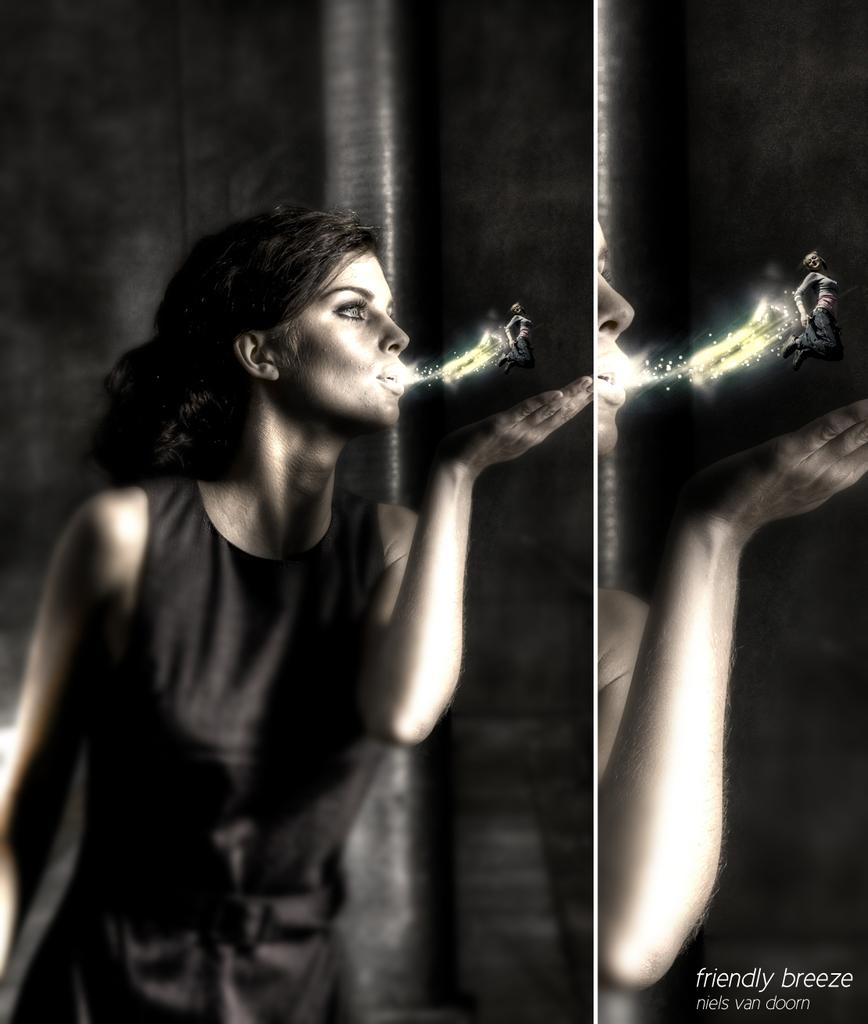What is the main subject of the image? There is a person in the image. What is the person doing in the image? The person is blowing a lilliput. What is special about the lilliput? The lilliput has spark. What can be found at the bottom of the image? There is text at the bottom of the image. How is the image composed? The image is a collage of two images. How many dogs are present in the image? There are no dogs present in the image. What type of picture is hanging on the wall in the image? There is no picture hanging on the wall in the image. 